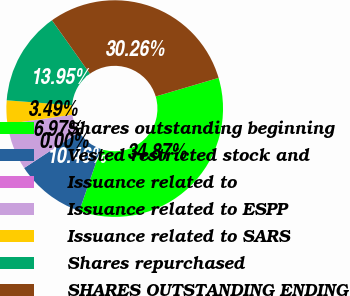Convert chart to OTSL. <chart><loc_0><loc_0><loc_500><loc_500><pie_chart><fcel>Shares outstanding beginning<fcel>Vested restricted stock and<fcel>Issuance related to<fcel>Issuance related to ESPP<fcel>Issuance related to SARS<fcel>Shares repurchased<fcel>SHARES OUTSTANDING ENDING<nl><fcel>34.87%<fcel>10.46%<fcel>0.0%<fcel>6.97%<fcel>3.49%<fcel>13.95%<fcel>30.26%<nl></chart> 